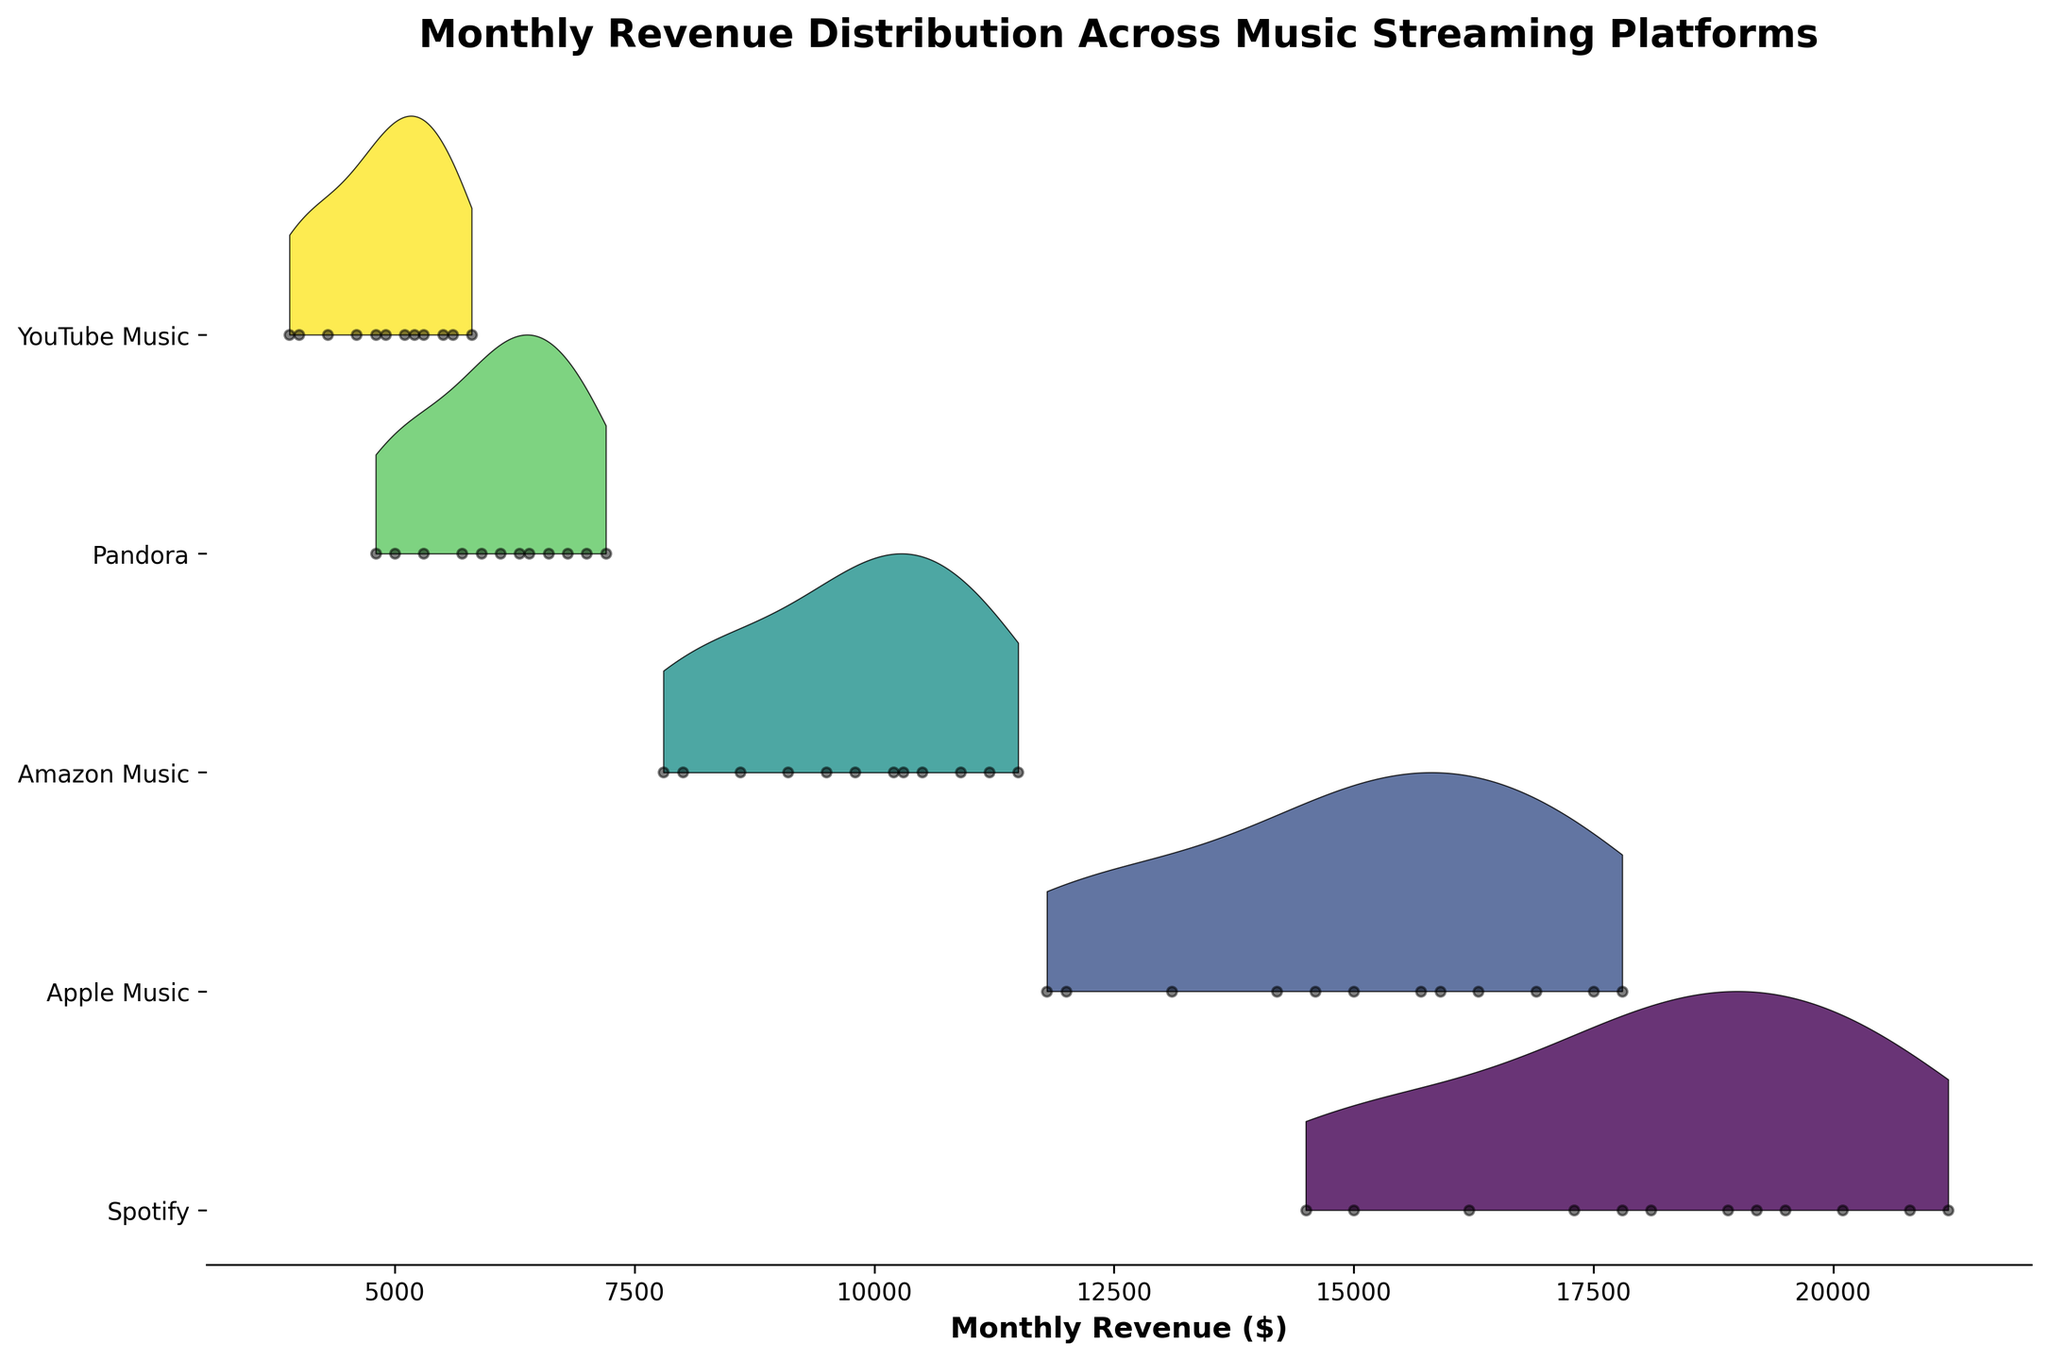Which platform has the highest average monthly revenue? To find the platform with the highest average monthly revenue, we sum the monthly revenues for each platform and then divide by the number of months. Based on the data in the figure, Spotify has consistently higher revenue figures, so its average would be the highest.
Answer: Spotify Which month shows the highest revenue for Apple Music? By examining the revenue data points for Apple Music across different months, we can see that July has the highest revenue for Apple Music.
Answer: July How does the revenue distribution for Pandora compare to that of Amazon Music in January? We can look at the kernel density estimations and specific data points in January for both Pandora and Amazon Music. Pandora has lower revenue distribution compared to Amazon Music in January, visible as a lower vertical position and smaller spread.
Answer: Pandora has a lower distribution than Amazon Music Identify the platform with the most consistent (least variable) revenue throughout the year. By looking at the spread of the kernels for each platform, we find that Apple Music has the most consistent revenue as indicated by the relatively narrower and more tightly packed curve.
Answer: Apple Music Which platform had the lowest revenue in any month, and in which month was this? Checking each platform’s lowest revenue points, YouTube Music in February had the lowest revenue figure of the entire dataset.
Answer: YouTube Music in February Which platform shows an increasing trend in revenue and how can you infer this from the plot? The increasing trend can be inferred from the data points and their arrangement. Spotify shows an increasing trend in revenue over the months as the points gradually move higher from the start to the end of the year.
Answer: Spotify In which month did Spotify see its highest revenue, and how can you identify it from the plot? The highest revenue for Spotify can be observed where the peak of the kernel density is at its maximum height. August shows the highest revenue for Spotify.
Answer: August Compare the revenue peaks of Spotify and Pandora. Which one is higher and by how much? By comparing the highest points in the kernel density estimation for each platform, Spotify’s peak around August is significantly higher than Pandora’s peak around July. The exact differences can be observed by comparing the values at these points.
Answer: Spotify's peak is higher Which two platforms have the closest revenue distributions, and how can this be identified? Platforms with closely aligned kernel density curves and peak positions have the closest revenue distributions. Apple Music and Amazon Music appear to have relatively closer distributions compared to others.
Answer: Apple Music and Amazon Music 